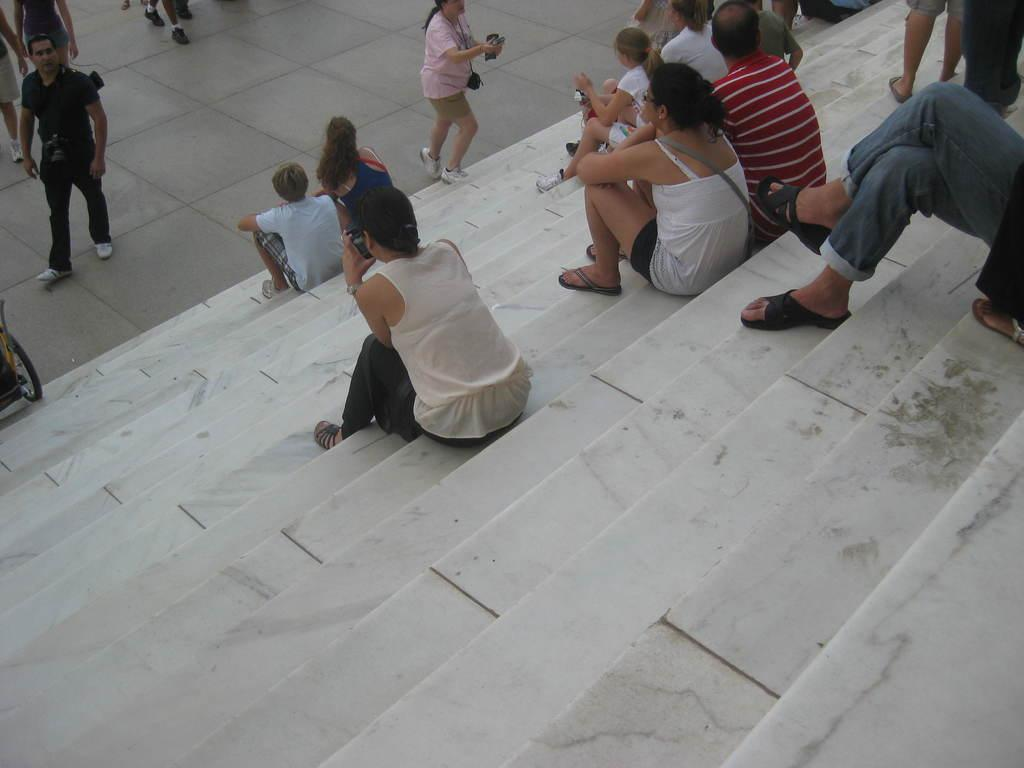What are the persons at the top of the image doing? The persons at the top of the image are standing. What is the surface they are standing on? They are standing on the floor. What are the persons at the bottom of the image doing? The persons at the bottom of the image are sitting. What are they sitting on? They are sitting on chairs. What type of shoe is visible on the person standing at the top of the image? There is no shoe visible on the person standing at the top of the image. 